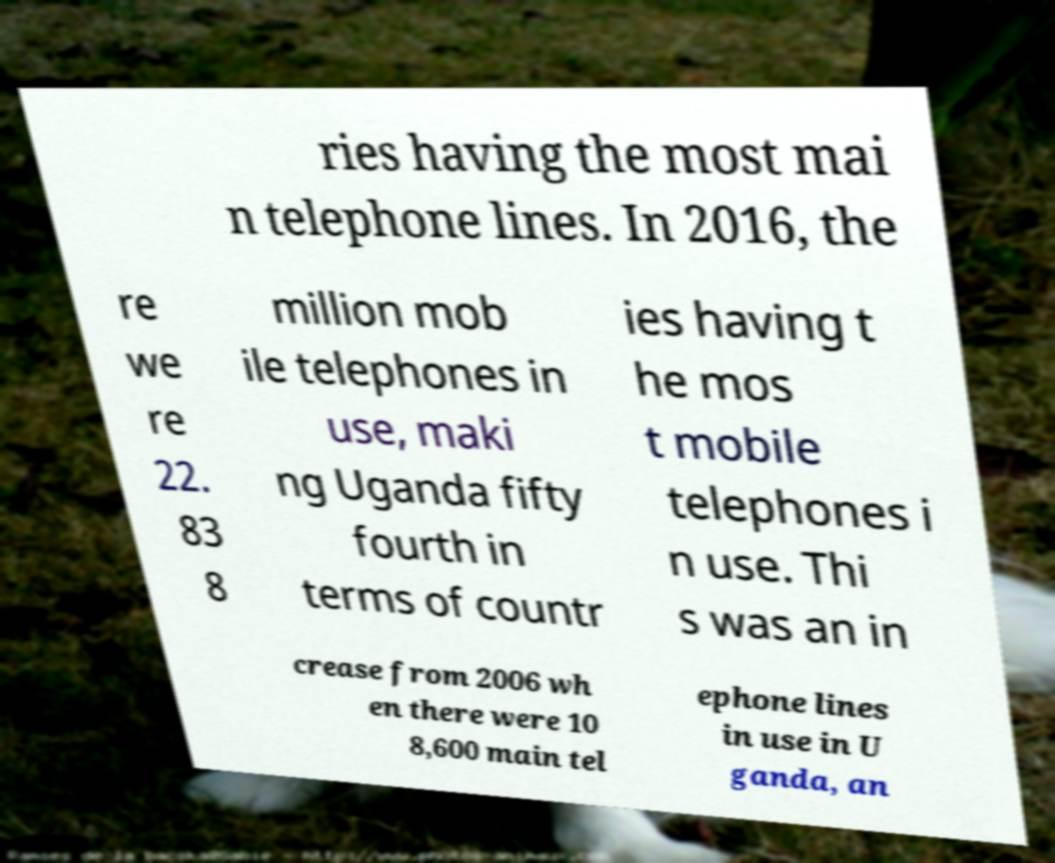Can you read and provide the text displayed in the image?This photo seems to have some interesting text. Can you extract and type it out for me? ries having the most mai n telephone lines. In 2016, the re we re 22. 83 8 million mob ile telephones in use, maki ng Uganda fifty fourth in terms of countr ies having t he mos t mobile telephones i n use. Thi s was an in crease from 2006 wh en there were 10 8,600 main tel ephone lines in use in U ganda, an 